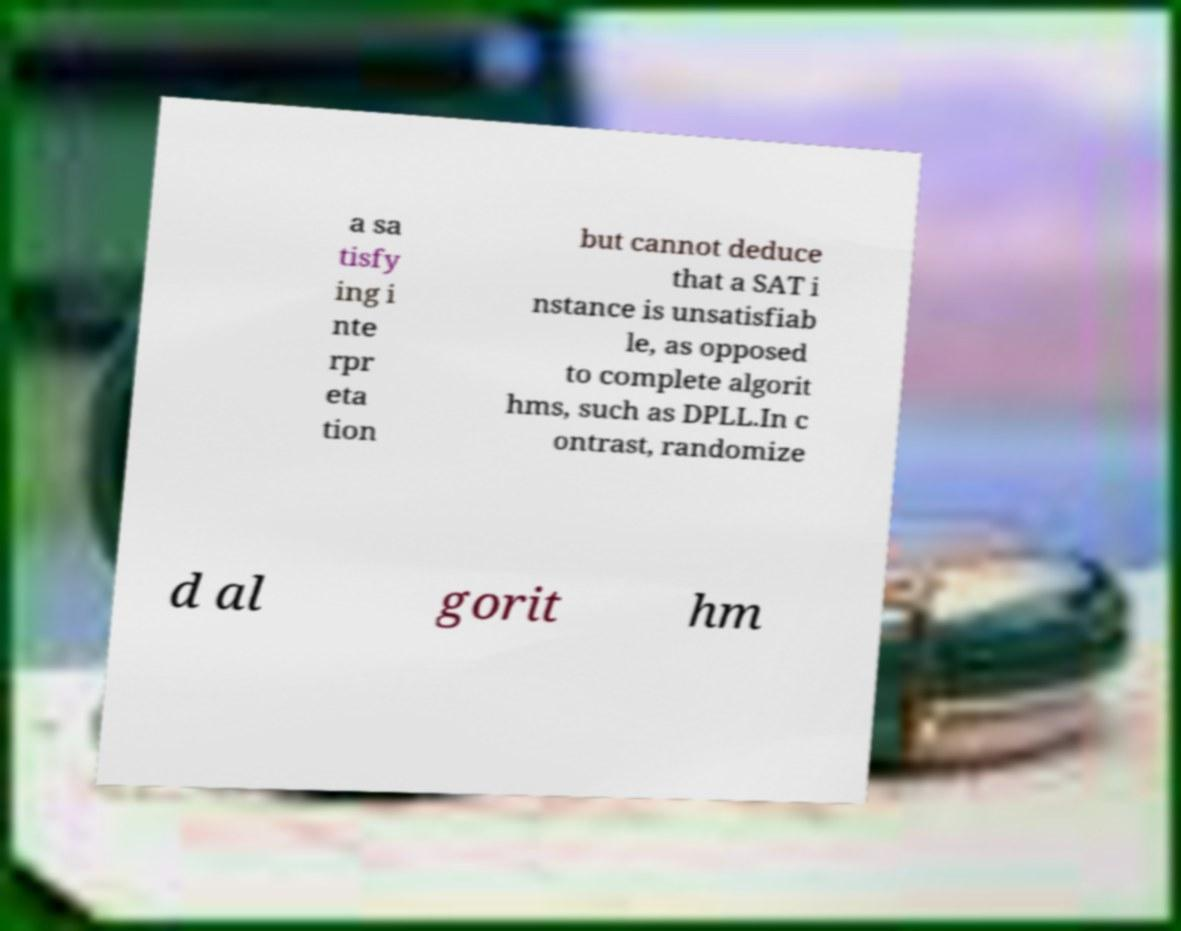Can you read and provide the text displayed in the image?This photo seems to have some interesting text. Can you extract and type it out for me? a sa tisfy ing i nte rpr eta tion but cannot deduce that a SAT i nstance is unsatisfiab le, as opposed to complete algorit hms, such as DPLL.In c ontrast, randomize d al gorit hm 